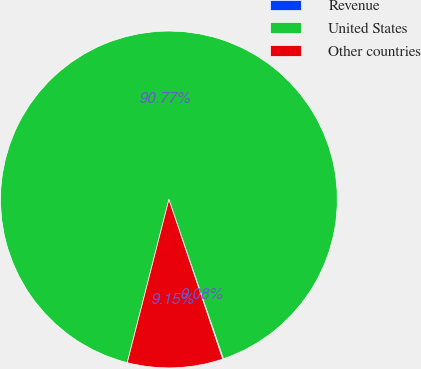<chart> <loc_0><loc_0><loc_500><loc_500><pie_chart><fcel>Revenue<fcel>United States<fcel>Other countries<nl><fcel>0.08%<fcel>90.78%<fcel>9.15%<nl></chart> 